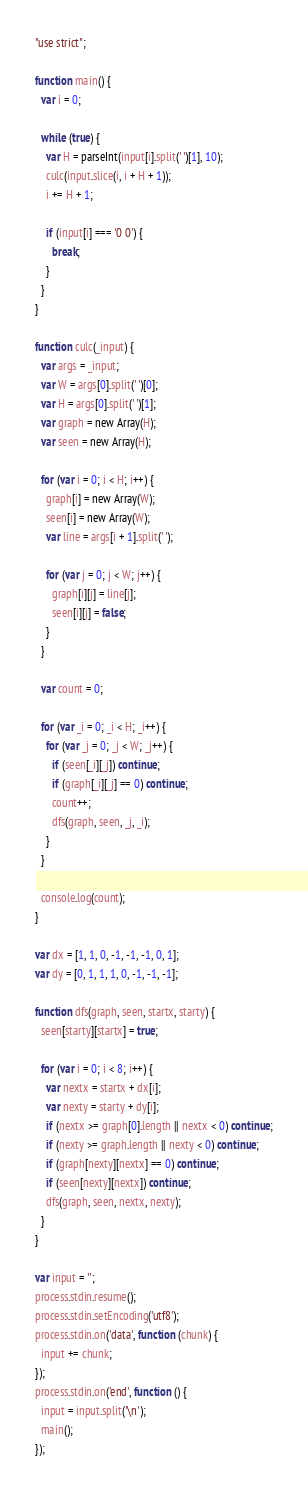<code> <loc_0><loc_0><loc_500><loc_500><_JavaScript_>"use strict";

function main() {
  var i = 0;

  while (true) {
    var H = parseInt(input[i].split(' ')[1], 10);
    culc(input.slice(i, i + H + 1));
    i += H + 1;

    if (input[i] === '0 0') {
      break;
    }
  }
}

function culc(_input) {
  var args = _input;
  var W = args[0].split(' ')[0];
  var H = args[0].split(' ')[1];
  var graph = new Array(H);
  var seen = new Array(H);

  for (var i = 0; i < H; i++) {
    graph[i] = new Array(W);
    seen[i] = new Array(W);
    var line = args[i + 1].split(' ');

    for (var j = 0; j < W; j++) {
      graph[i][j] = line[j];
      seen[i][j] = false;
    }
  }

  var count = 0;

  for (var _i = 0; _i < H; _i++) {
    for (var _j = 0; _j < W; _j++) {
      if (seen[_i][_j]) continue;
      if (graph[_i][_j] == 0) continue;
      count++;
      dfs(graph, seen, _j, _i);
    }
  }

  console.log(count);
}

var dx = [1, 1, 0, -1, -1, -1, 0, 1];
var dy = [0, 1, 1, 1, 0, -1, -1, -1];

function dfs(graph, seen, startx, starty) {
  seen[starty][startx] = true;

  for (var i = 0; i < 8; i++) {
    var nextx = startx + dx[i];
    var nexty = starty + dy[i];
    if (nextx >= graph[0].length || nextx < 0) continue;
    if (nexty >= graph.length || nexty < 0) continue;
    if (graph[nexty][nextx] == 0) continue;
    if (seen[nexty][nextx]) continue;
    dfs(graph, seen, nextx, nexty);
  }
}

var input = '';
process.stdin.resume();
process.stdin.setEncoding('utf8');
process.stdin.on('data', function (chunk) {
  input += chunk;
});
process.stdin.on('end', function () {
  input = input.split('\n');
  main();
});
</code> 